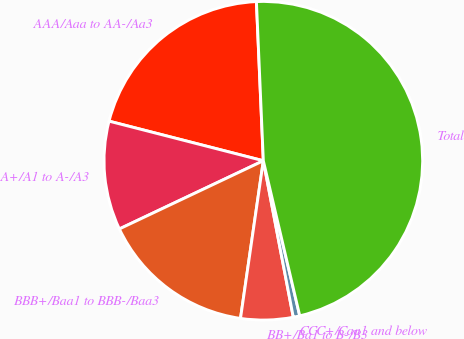<chart> <loc_0><loc_0><loc_500><loc_500><pie_chart><fcel>AAA/Aaa to AA-/Aa3<fcel>A+/A1 to A-/A3<fcel>BBB+/Baa1 to BBB-/Baa3<fcel>BB+/Ba1 to B-/B3<fcel>CCC+/Caa1 and below<fcel>Total<nl><fcel>20.31%<fcel>11.04%<fcel>15.67%<fcel>5.3%<fcel>0.66%<fcel>47.02%<nl></chart> 